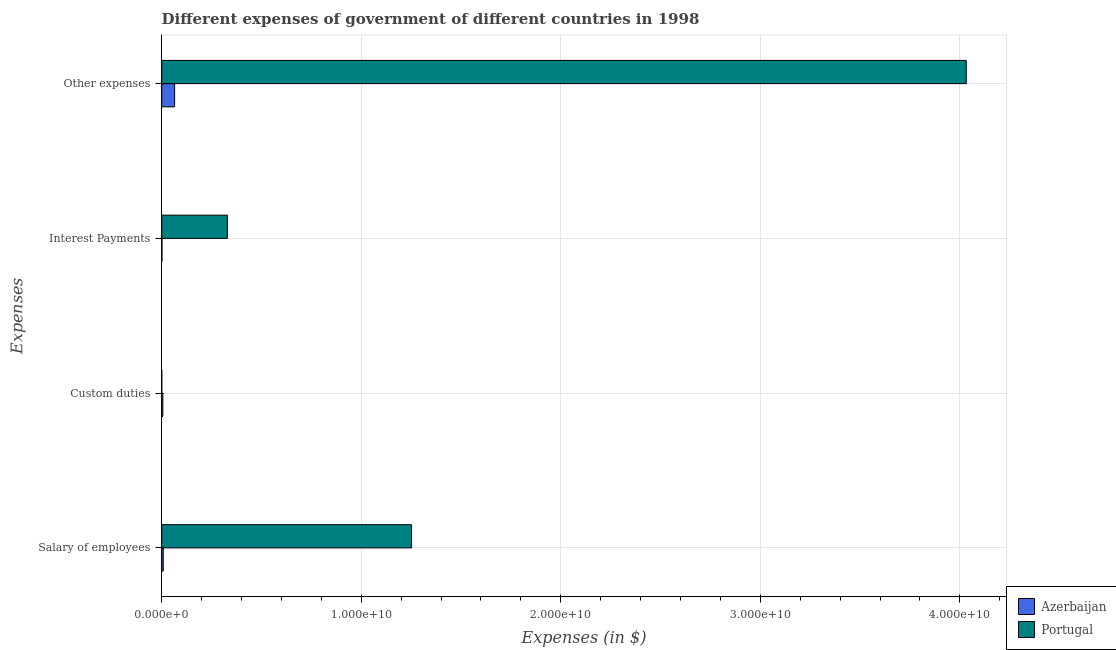How many groups of bars are there?
Your answer should be very brief. 4. How many bars are there on the 3rd tick from the top?
Keep it short and to the point. 2. What is the label of the 2nd group of bars from the top?
Provide a short and direct response. Interest Payments. What is the amount spent on interest payments in Portugal?
Offer a very short reply. 3.29e+09. Across all countries, what is the maximum amount spent on salary of employees?
Offer a terse response. 1.25e+1. Across all countries, what is the minimum amount spent on custom duties?
Offer a terse response. 2.33e+06. In which country was the amount spent on other expenses maximum?
Offer a terse response. Portugal. In which country was the amount spent on salary of employees minimum?
Your answer should be very brief. Azerbaijan. What is the total amount spent on other expenses in the graph?
Ensure brevity in your answer.  4.10e+1. What is the difference between the amount spent on salary of employees in Azerbaijan and that in Portugal?
Your response must be concise. -1.24e+1. What is the difference between the amount spent on interest payments in Azerbaijan and the amount spent on other expenses in Portugal?
Provide a short and direct response. -4.03e+1. What is the average amount spent on salary of employees per country?
Offer a very short reply. 6.30e+09. What is the difference between the amount spent on salary of employees and amount spent on other expenses in Portugal?
Offer a very short reply. -2.78e+1. What is the ratio of the amount spent on interest payments in Portugal to that in Azerbaijan?
Offer a terse response. 268.1. What is the difference between the highest and the second highest amount spent on interest payments?
Offer a very short reply. 3.28e+09. What is the difference between the highest and the lowest amount spent on custom duties?
Your answer should be very brief. 5.37e+07. In how many countries, is the amount spent on other expenses greater than the average amount spent on other expenses taken over all countries?
Your answer should be compact. 1. Is the sum of the amount spent on other expenses in Azerbaijan and Portugal greater than the maximum amount spent on custom duties across all countries?
Provide a succinct answer. Yes. Is it the case that in every country, the sum of the amount spent on other expenses and amount spent on salary of employees is greater than the sum of amount spent on interest payments and amount spent on custom duties?
Ensure brevity in your answer.  No. What does the 2nd bar from the top in Other expenses represents?
Your response must be concise. Azerbaijan. Is it the case that in every country, the sum of the amount spent on salary of employees and amount spent on custom duties is greater than the amount spent on interest payments?
Provide a short and direct response. Yes. How many countries are there in the graph?
Make the answer very short. 2. What is the difference between two consecutive major ticks on the X-axis?
Make the answer very short. 1.00e+1. Are the values on the major ticks of X-axis written in scientific E-notation?
Provide a short and direct response. Yes. How many legend labels are there?
Provide a succinct answer. 2. How are the legend labels stacked?
Offer a terse response. Vertical. What is the title of the graph?
Keep it short and to the point. Different expenses of government of different countries in 1998. Does "Afghanistan" appear as one of the legend labels in the graph?
Your answer should be very brief. No. What is the label or title of the X-axis?
Provide a short and direct response. Expenses (in $). What is the label or title of the Y-axis?
Your answer should be compact. Expenses. What is the Expenses (in $) in Azerbaijan in Salary of employees?
Offer a very short reply. 7.66e+07. What is the Expenses (in $) of Portugal in Salary of employees?
Provide a succinct answer. 1.25e+1. What is the Expenses (in $) in Azerbaijan in Custom duties?
Provide a short and direct response. 5.60e+07. What is the Expenses (in $) in Portugal in Custom duties?
Your response must be concise. 2.33e+06. What is the Expenses (in $) in Azerbaijan in Interest Payments?
Your response must be concise. 1.23e+07. What is the Expenses (in $) of Portugal in Interest Payments?
Give a very brief answer. 3.29e+09. What is the Expenses (in $) in Azerbaijan in Other expenses?
Offer a very short reply. 6.46e+08. What is the Expenses (in $) of Portugal in Other expenses?
Your answer should be compact. 4.03e+1. Across all Expenses, what is the maximum Expenses (in $) of Azerbaijan?
Keep it short and to the point. 6.46e+08. Across all Expenses, what is the maximum Expenses (in $) of Portugal?
Offer a terse response. 4.03e+1. Across all Expenses, what is the minimum Expenses (in $) of Azerbaijan?
Give a very brief answer. 1.23e+07. Across all Expenses, what is the minimum Expenses (in $) in Portugal?
Provide a short and direct response. 2.33e+06. What is the total Expenses (in $) in Azerbaijan in the graph?
Give a very brief answer. 7.91e+08. What is the total Expenses (in $) in Portugal in the graph?
Give a very brief answer. 5.61e+1. What is the difference between the Expenses (in $) of Azerbaijan in Salary of employees and that in Custom duties?
Offer a terse response. 2.06e+07. What is the difference between the Expenses (in $) in Portugal in Salary of employees and that in Custom duties?
Make the answer very short. 1.25e+1. What is the difference between the Expenses (in $) in Azerbaijan in Salary of employees and that in Interest Payments?
Keep it short and to the point. 6.43e+07. What is the difference between the Expenses (in $) in Portugal in Salary of employees and that in Interest Payments?
Offer a terse response. 9.23e+09. What is the difference between the Expenses (in $) of Azerbaijan in Salary of employees and that in Other expenses?
Ensure brevity in your answer.  -5.69e+08. What is the difference between the Expenses (in $) of Portugal in Salary of employees and that in Other expenses?
Offer a very short reply. -2.78e+1. What is the difference between the Expenses (in $) of Azerbaijan in Custom duties and that in Interest Payments?
Your answer should be compact. 4.37e+07. What is the difference between the Expenses (in $) of Portugal in Custom duties and that in Interest Payments?
Ensure brevity in your answer.  -3.29e+09. What is the difference between the Expenses (in $) in Azerbaijan in Custom duties and that in Other expenses?
Offer a terse response. -5.90e+08. What is the difference between the Expenses (in $) of Portugal in Custom duties and that in Other expenses?
Make the answer very short. -4.03e+1. What is the difference between the Expenses (in $) in Azerbaijan in Interest Payments and that in Other expenses?
Offer a terse response. -6.33e+08. What is the difference between the Expenses (in $) of Portugal in Interest Payments and that in Other expenses?
Your answer should be compact. -3.70e+1. What is the difference between the Expenses (in $) in Azerbaijan in Salary of employees and the Expenses (in $) in Portugal in Custom duties?
Keep it short and to the point. 7.43e+07. What is the difference between the Expenses (in $) in Azerbaijan in Salary of employees and the Expenses (in $) in Portugal in Interest Payments?
Your response must be concise. -3.22e+09. What is the difference between the Expenses (in $) of Azerbaijan in Salary of employees and the Expenses (in $) of Portugal in Other expenses?
Keep it short and to the point. -4.02e+1. What is the difference between the Expenses (in $) of Azerbaijan in Custom duties and the Expenses (in $) of Portugal in Interest Payments?
Ensure brevity in your answer.  -3.24e+09. What is the difference between the Expenses (in $) in Azerbaijan in Custom duties and the Expenses (in $) in Portugal in Other expenses?
Provide a succinct answer. -4.03e+1. What is the difference between the Expenses (in $) in Azerbaijan in Interest Payments and the Expenses (in $) in Portugal in Other expenses?
Make the answer very short. -4.03e+1. What is the average Expenses (in $) of Azerbaijan per Expenses?
Ensure brevity in your answer.  1.98e+08. What is the average Expenses (in $) of Portugal per Expenses?
Your answer should be very brief. 1.40e+1. What is the difference between the Expenses (in $) of Azerbaijan and Expenses (in $) of Portugal in Salary of employees?
Provide a succinct answer. -1.24e+1. What is the difference between the Expenses (in $) of Azerbaijan and Expenses (in $) of Portugal in Custom duties?
Provide a short and direct response. 5.37e+07. What is the difference between the Expenses (in $) in Azerbaijan and Expenses (in $) in Portugal in Interest Payments?
Provide a succinct answer. -3.28e+09. What is the difference between the Expenses (in $) in Azerbaijan and Expenses (in $) in Portugal in Other expenses?
Your answer should be very brief. -3.97e+1. What is the ratio of the Expenses (in $) in Azerbaijan in Salary of employees to that in Custom duties?
Offer a terse response. 1.37. What is the ratio of the Expenses (in $) of Portugal in Salary of employees to that in Custom duties?
Your answer should be very brief. 5373.8. What is the ratio of the Expenses (in $) in Azerbaijan in Salary of employees to that in Interest Payments?
Ensure brevity in your answer.  6.24. What is the ratio of the Expenses (in $) of Portugal in Salary of employees to that in Interest Payments?
Provide a succinct answer. 3.8. What is the ratio of the Expenses (in $) in Azerbaijan in Salary of employees to that in Other expenses?
Make the answer very short. 0.12. What is the ratio of the Expenses (in $) of Portugal in Salary of employees to that in Other expenses?
Your response must be concise. 0.31. What is the ratio of the Expenses (in $) in Azerbaijan in Custom duties to that in Interest Payments?
Provide a short and direct response. 4.56. What is the ratio of the Expenses (in $) of Portugal in Custom duties to that in Interest Payments?
Keep it short and to the point. 0. What is the ratio of the Expenses (in $) of Azerbaijan in Custom duties to that in Other expenses?
Your answer should be very brief. 0.09. What is the ratio of the Expenses (in $) of Portugal in Custom duties to that in Other expenses?
Your response must be concise. 0. What is the ratio of the Expenses (in $) in Azerbaijan in Interest Payments to that in Other expenses?
Offer a terse response. 0.02. What is the ratio of the Expenses (in $) in Portugal in Interest Payments to that in Other expenses?
Your answer should be very brief. 0.08. What is the difference between the highest and the second highest Expenses (in $) of Azerbaijan?
Keep it short and to the point. 5.69e+08. What is the difference between the highest and the second highest Expenses (in $) of Portugal?
Your answer should be compact. 2.78e+1. What is the difference between the highest and the lowest Expenses (in $) of Azerbaijan?
Your answer should be very brief. 6.33e+08. What is the difference between the highest and the lowest Expenses (in $) in Portugal?
Your answer should be compact. 4.03e+1. 